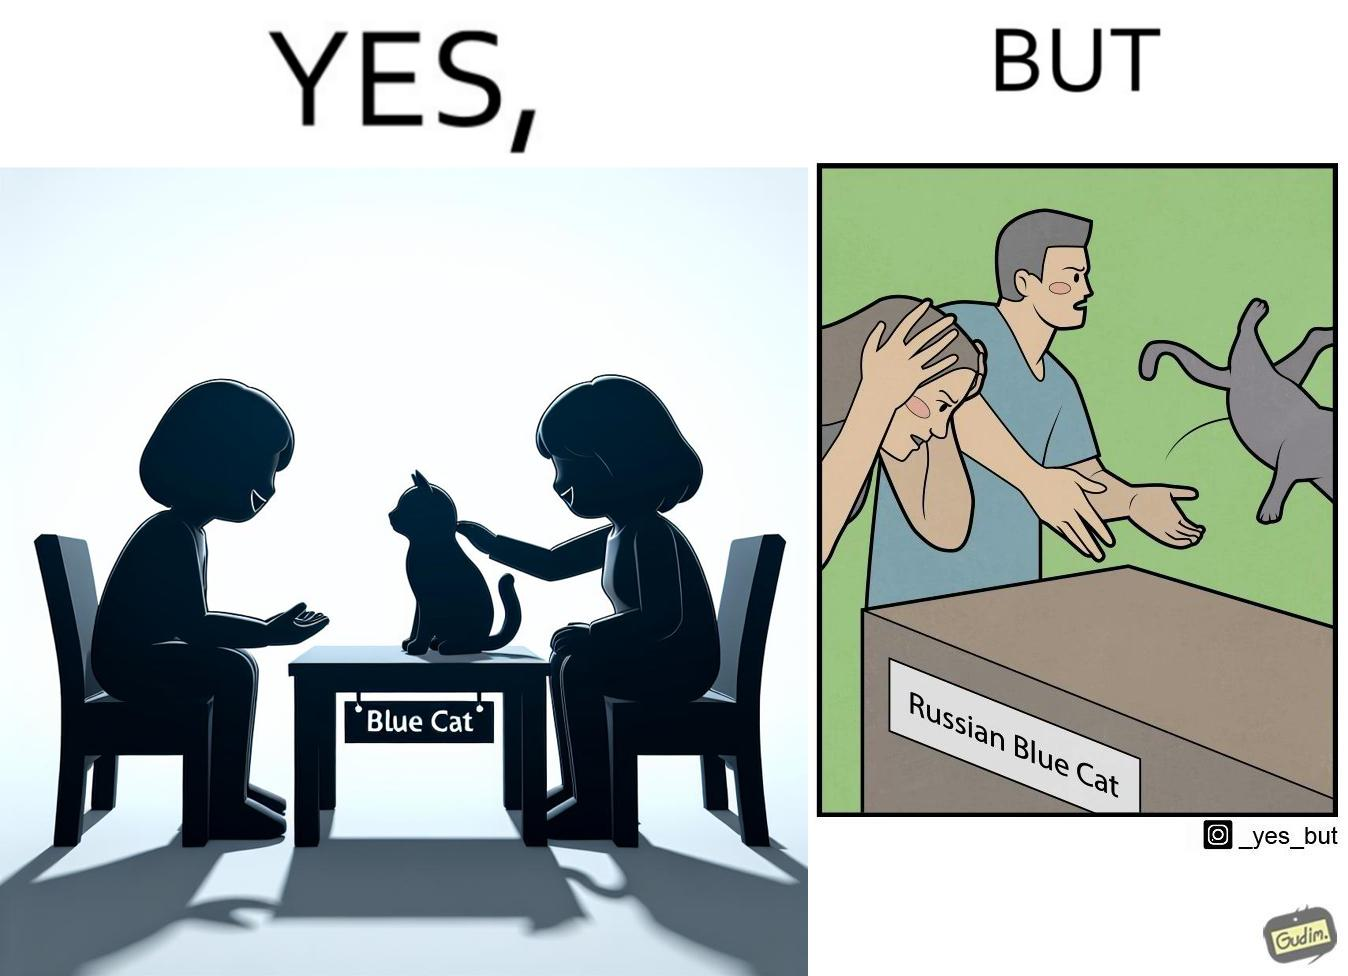What does this image depict? The image is confusing, as initially, when the label reads "Blue Cat", the people are happy and are petting tha cat, but as soon as one of them realizes that the entire text reads "Russian Blue Cat", they seem to worried, and one of them throws away the cat. For some reason, the word "Russian" is a trigger word for them. 